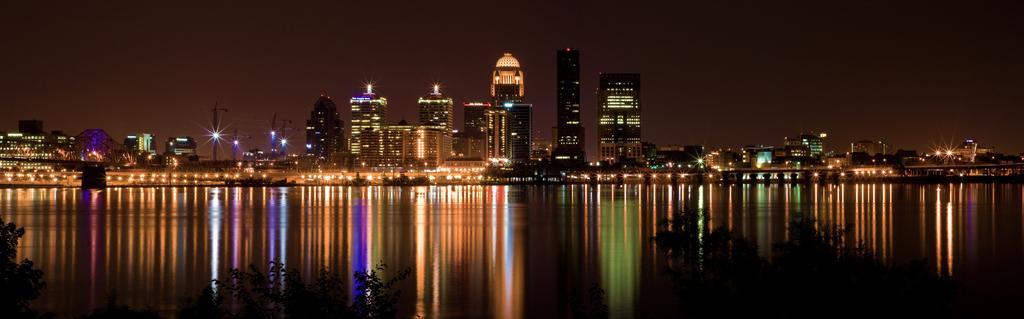Could you give a brief overview of what you see in this image? In this image there are buildings and lights. At the bottom there is water and trees. In the background there is sky. 